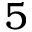<formula> <loc_0><loc_0><loc_500><loc_500>5</formula> 